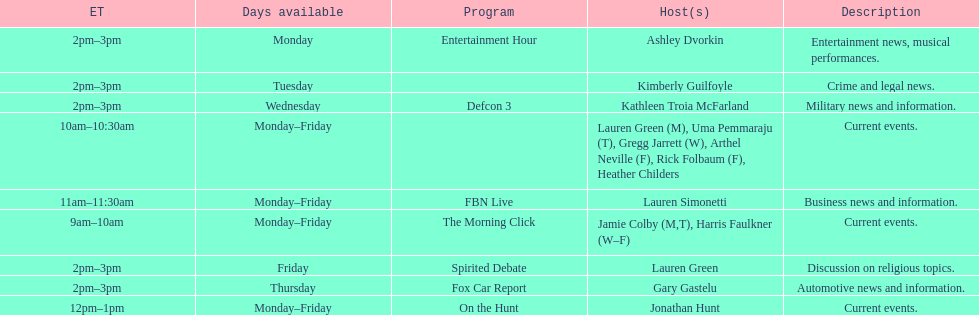How long does on the hunt run? 1 hour. 